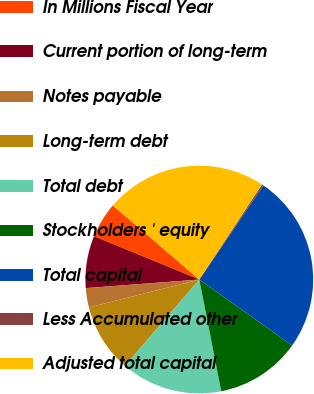Convert chart. <chart><loc_0><loc_0><loc_500><loc_500><pie_chart><fcel>In Millions Fiscal Year<fcel>Current portion of long-term<fcel>Notes payable<fcel>Long-term debt<fcel>Total debt<fcel>Stockholders ' equity<fcel>Total capital<fcel>Less Accumulated other<fcel>Adjusted total capital<nl><fcel>5.07%<fcel>7.41%<fcel>2.74%<fcel>9.74%<fcel>14.41%<fcel>12.08%<fcel>25.33%<fcel>0.23%<fcel>23.0%<nl></chart> 